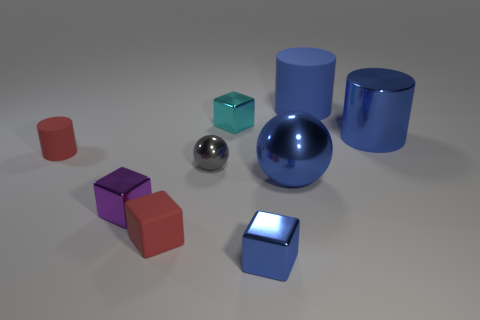Subtract all rubber cylinders. How many cylinders are left? 1 Subtract all blue cylinders. How many cylinders are left? 1 Subtract all spheres. How many objects are left? 7 Subtract 1 balls. How many balls are left? 1 Subtract all small gray spheres. Subtract all big yellow objects. How many objects are left? 8 Add 9 large blue metallic cylinders. How many large blue metallic cylinders are left? 10 Add 2 cyan things. How many cyan things exist? 3 Subtract 1 red cylinders. How many objects are left? 8 Subtract all cyan blocks. Subtract all yellow spheres. How many blocks are left? 3 Subtract all red blocks. How many green cylinders are left? 0 